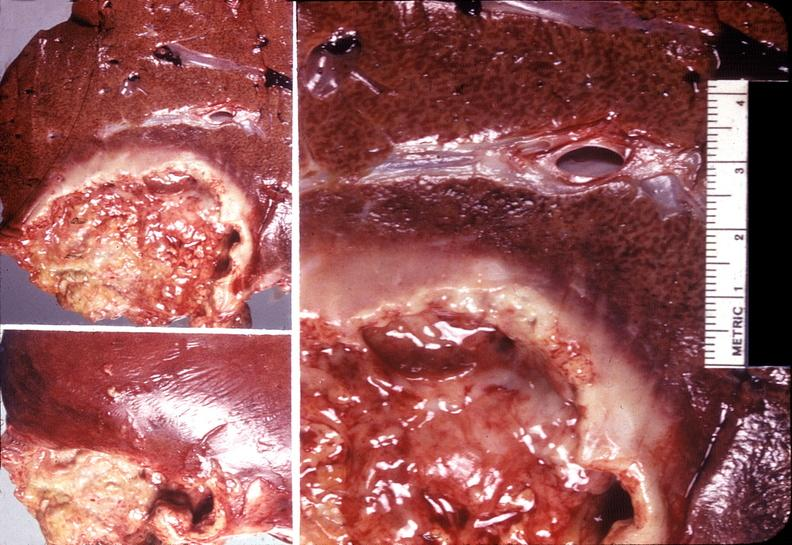does candida in peripheral blood show liver, ameobic abscesses?
Answer the question using a single word or phrase. No 